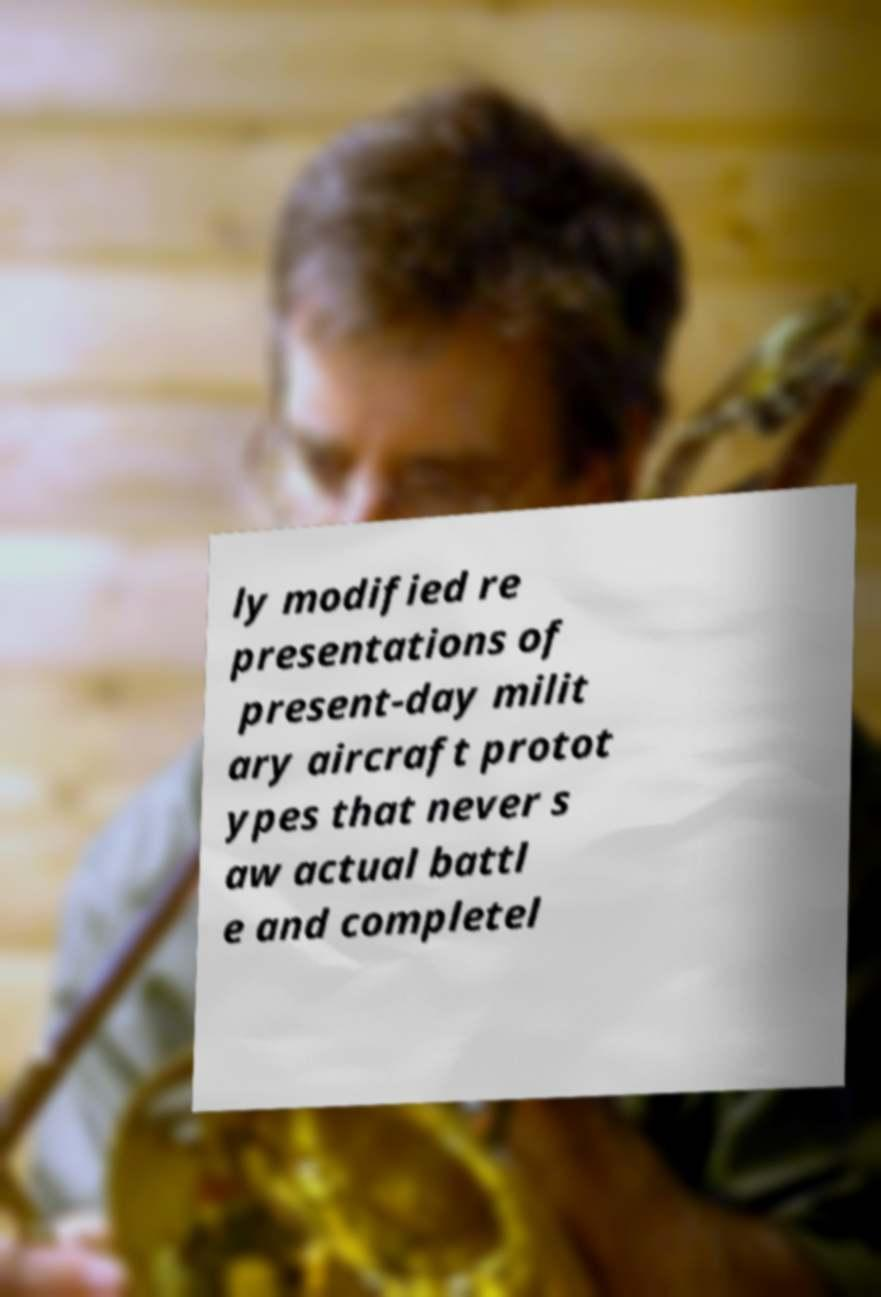For documentation purposes, I need the text within this image transcribed. Could you provide that? ly modified re presentations of present-day milit ary aircraft protot ypes that never s aw actual battl e and completel 